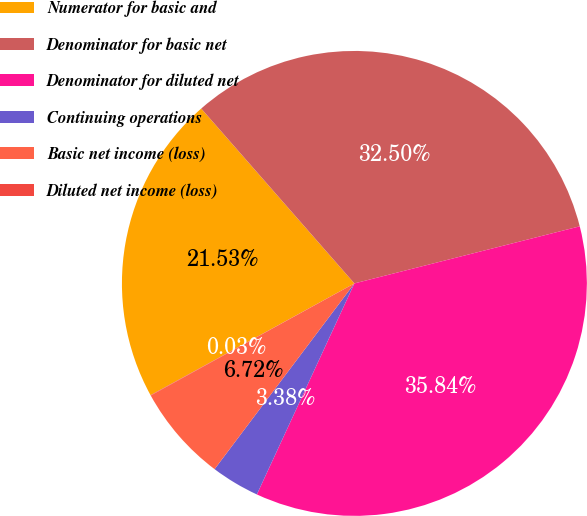Convert chart. <chart><loc_0><loc_0><loc_500><loc_500><pie_chart><fcel>Numerator for basic and<fcel>Denominator for basic net<fcel>Denominator for diluted net<fcel>Continuing operations<fcel>Basic net income (loss)<fcel>Diluted net income (loss)<nl><fcel>21.53%<fcel>32.5%<fcel>35.84%<fcel>3.38%<fcel>6.72%<fcel>0.03%<nl></chart> 